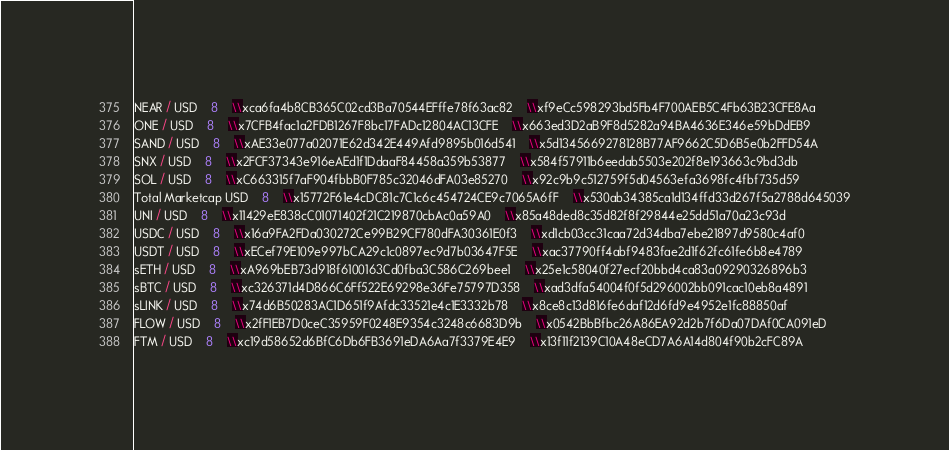Convert code to text. <code><loc_0><loc_0><loc_500><loc_500><_SQL_>NEAR / USD	8	\\xca6fa4b8CB365C02cd3Ba70544EFffe78f63ac82	\\xf9eCc598293bd5Fb4F700AEB5C4Fb63B23CFE8Aa
ONE / USD	8	\\x7CFB4fac1a2FDB1267F8bc17FADc12804AC13CFE	\\x663ed3D2aB9F8d5282a94BA4636E346e59bDdEB9
SAND / USD	8	\\xAE33e077a02071E62d342E449Afd9895b016d541	\\x5d1345669278128B77AF9662C5D6B5e0b2FFD54A
SNX / USD	8	\\x2FCF37343e916eAEd1f1DdaaF84458a359b53877	\\x584f57911b6eedab5503e202f8e193663c9bd3db
SOL / USD	8	\\xC663315f7aF904fbbB0F785c32046dFA03e85270	\\x92c9b9c512759f5d04563efa3698fc4fbf735d59
Total Marketcap USD	8	\\x15772F61e4cDC81c7C1c6c454724CE9c7065A6fF	\\x530ab34385ca1d134ffd33d267f5a2788d645039
UNI / USD	8	\\x11429eE838cC01071402f21C219870cbAc0a59A0	\\x85a48ded8c35d82f8f29844e25dd51a70a23c93d
USDC / USD	8	\\x16a9FA2FDa030272Ce99B29CF780dFA30361E0f3	\\xd1cb03cc31caa72d34dba7ebe21897d9580c4af0
USDT / USD	8	\\xECef79E109e997bCA29c1c0897ec9d7b03647F5E	\\xac37790ff4abf9483fae2d1f62fc61fe6b8e4789
sETH / USD	8	\\xA969bEB73d918f6100163Cd0fba3C586C269bee1	\\x25e1c58040f27ecf20bbd4ca83a09290326896b3
sBTC / USD	8	\\xc326371d4D866C6Ff522E69298e36Fe75797D358	\\xad3dfa54004f0f5d296002bb091cac10eb8a4891
sLINK / USD	8	\\x74d6B50283AC1D651f9Afdc33521e4c1E3332b78	\\x8ce8c13d816fe6daf12d6fd9e4952e1fc88850af
FLOW / USD	8	\\x2fF1EB7D0ceC35959F0248E9354c3248c6683D9b	\\x0542BbBfbc26A86EA92d2b7f6Da07DAf0CA091eD
FTM / USD	8	\\xc19d58652d6BfC6Db6FB3691eDA6Aa7f3379E4E9	\\x13f11f2139C10A48eCD7A6A14d804f90b2cFC89A</code> 